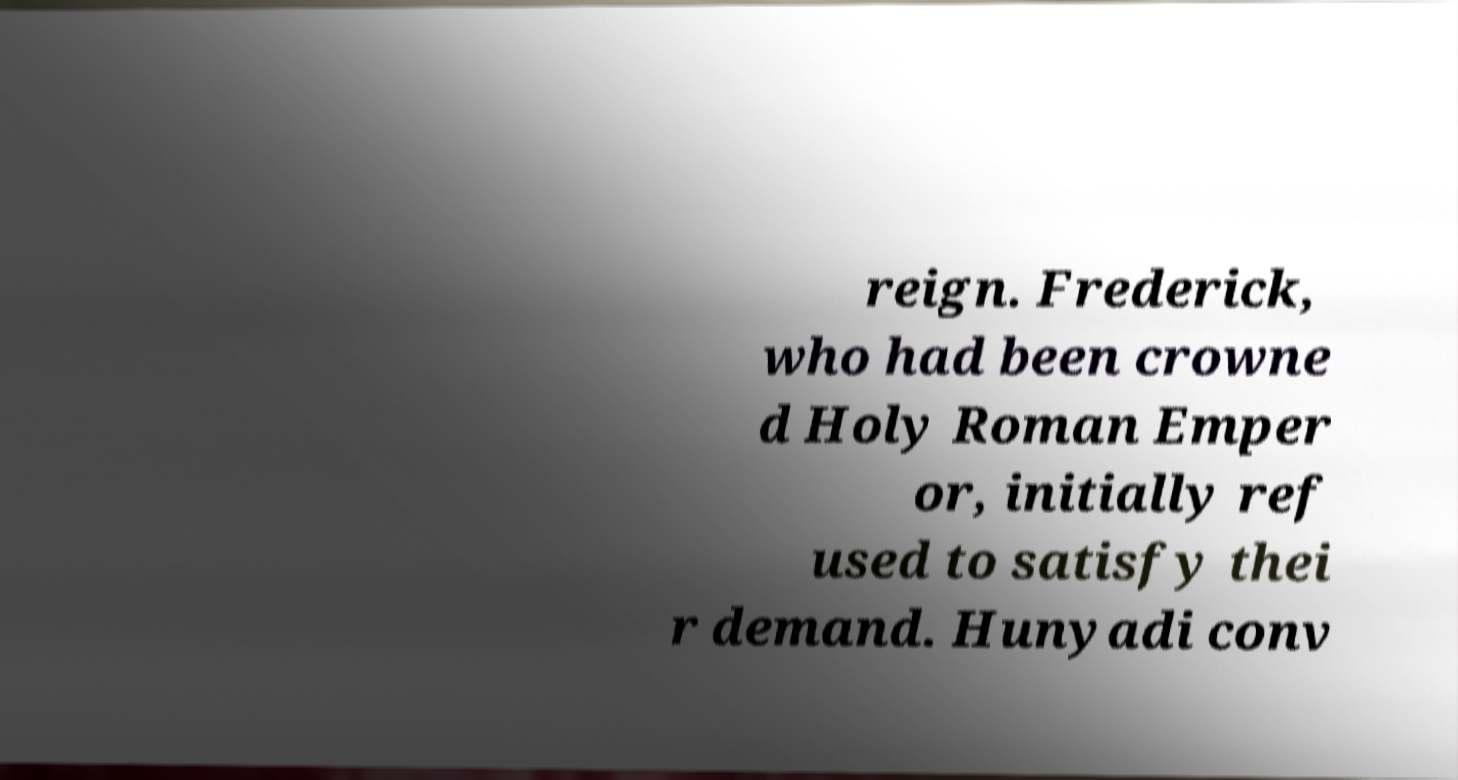Can you accurately transcribe the text from the provided image for me? reign. Frederick, who had been crowne d Holy Roman Emper or, initially ref used to satisfy thei r demand. Hunyadi conv 